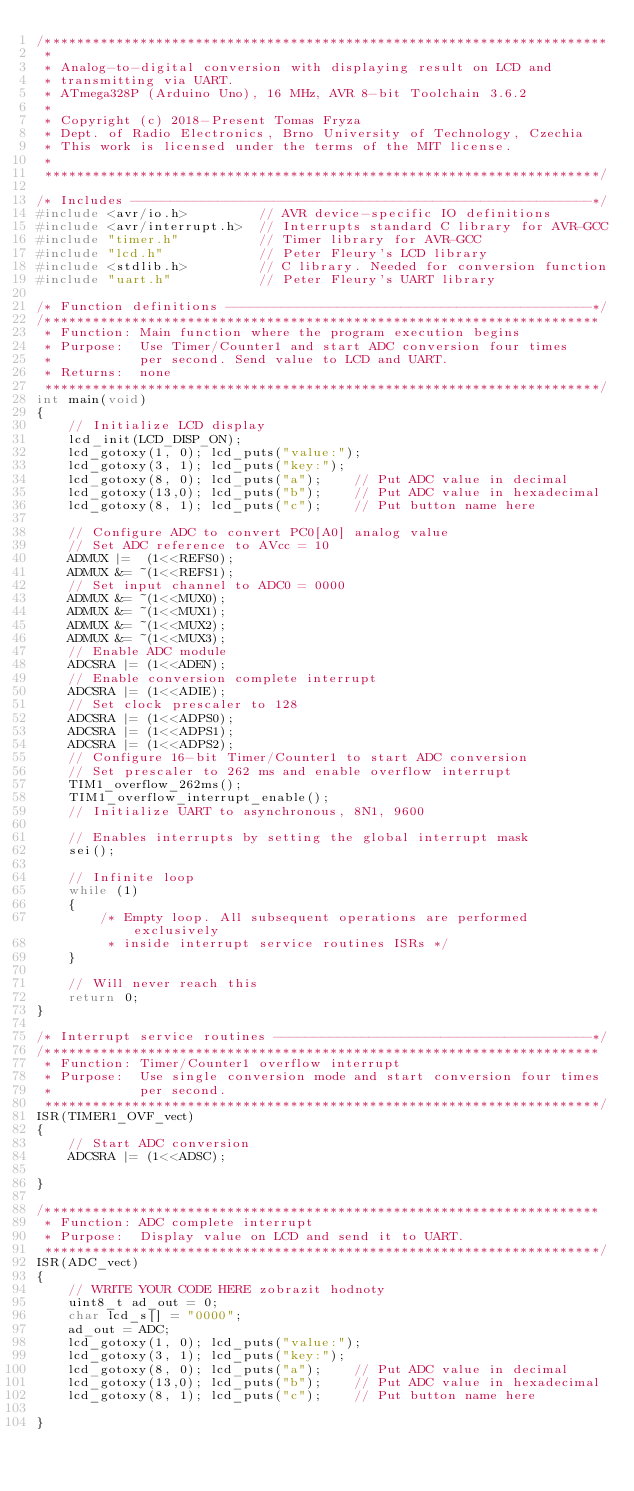<code> <loc_0><loc_0><loc_500><loc_500><_C_>/***********************************************************************
 * 
 * Analog-to-digital conversion with displaying result on LCD and 
 * transmitting via UART.
 * ATmega328P (Arduino Uno), 16 MHz, AVR 8-bit Toolchain 3.6.2
 *
 * Copyright (c) 2018-Present Tomas Fryza
 * Dept. of Radio Electronics, Brno University of Technology, Czechia
 * This work is licensed under the terms of the MIT license.
 * 
 **********************************************************************/

/* Includes ----------------------------------------------------------*/
#include <avr/io.h>         // AVR device-specific IO definitions
#include <avr/interrupt.h>  // Interrupts standard C library for AVR-GCC
#include "timer.h"          // Timer library for AVR-GCC
#include "lcd.h"            // Peter Fleury's LCD library
#include <stdlib.h>         // C library. Needed for conversion function
#include "uart.h"           // Peter Fleury's UART library

/* Function definitions ----------------------------------------------*/
/**********************************************************************
 * Function: Main function where the program execution begins
 * Purpose:  Use Timer/Counter1 and start ADC conversion four times 
 *           per second. Send value to LCD and UART.
 * Returns:  none
 **********************************************************************/
int main(void)
{
    // Initialize LCD display
    lcd_init(LCD_DISP_ON);
    lcd_gotoxy(1, 0); lcd_puts("value:");
    lcd_gotoxy(3, 1); lcd_puts("key:");
    lcd_gotoxy(8, 0); lcd_puts("a");    // Put ADC value in decimal
    lcd_gotoxy(13,0); lcd_puts("b");    // Put ADC value in hexadecimal
    lcd_gotoxy(8, 1); lcd_puts("c");    // Put button name here

    // Configure ADC to convert PC0[A0] analog value
    // Set ADC reference to AVcc = 10
    ADMUX |=  (1<<REFS0);
    ADMUX &= ~(1<<REFS1); 
    // Set input channel to ADC0 = 0000
    ADMUX &= ~(1<<MUX0);
    ADMUX &= ~(1<<MUX1);
    ADMUX &= ~(1<<MUX2);
    ADMUX &= ~(1<<MUX3);
    // Enable ADC module
    ADCSRA |= (1<<ADEN);
    // Enable conversion complete interrupt
    ADCSRA |= (1<<ADIE);
    // Set clock prescaler to 128
    ADCSRA |= (1<<ADPS0);
    ADCSRA |= (1<<ADPS1);
    ADCSRA |= (1<<ADPS2);
    // Configure 16-bit Timer/Counter1 to start ADC conversion
    // Set prescaler to 262 ms and enable overflow interrupt
    TIM1_overflow_262ms();
    TIM1_overflow_interrupt_enable();
    // Initialize UART to asynchronous, 8N1, 9600
    
    // Enables interrupts by setting the global interrupt mask
    sei();

    // Infinite loop
    while (1)
    {
        /* Empty loop. All subsequent operations are performed exclusively 
         * inside interrupt service routines ISRs */
    }

    // Will never reach this
    return 0;
}

/* Interrupt service routines ----------------------------------------*/
/**********************************************************************
 * Function: Timer/Counter1 overflow interrupt
 * Purpose:  Use single conversion mode and start conversion four times
 *           per second.
 **********************************************************************/
ISR(TIMER1_OVF_vect)
{
    // Start ADC conversion
    ADCSRA |= (1<<ADSC);

}

/**********************************************************************
 * Function: ADC complete interrupt
 * Purpose:  Display value on LCD and send it to UART.
 **********************************************************************/
ISR(ADC_vect)
{
    // WRITE YOUR CODE HERE zobrazit hodnoty
    uint8_t ad_out = 0;
    char lcd_s[] = "0000";
    ad_out = ADC;
    lcd_gotoxy(1, 0); lcd_puts("value:");
    lcd_gotoxy(3, 1); lcd_puts("key:");
    lcd_gotoxy(8, 0); lcd_puts("a");    // Put ADC value in decimal
    lcd_gotoxy(13,0); lcd_puts("b");    // Put ADC value in hexadecimal
    lcd_gotoxy(8, 1); lcd_puts("c");    // Put button name here

}</code> 